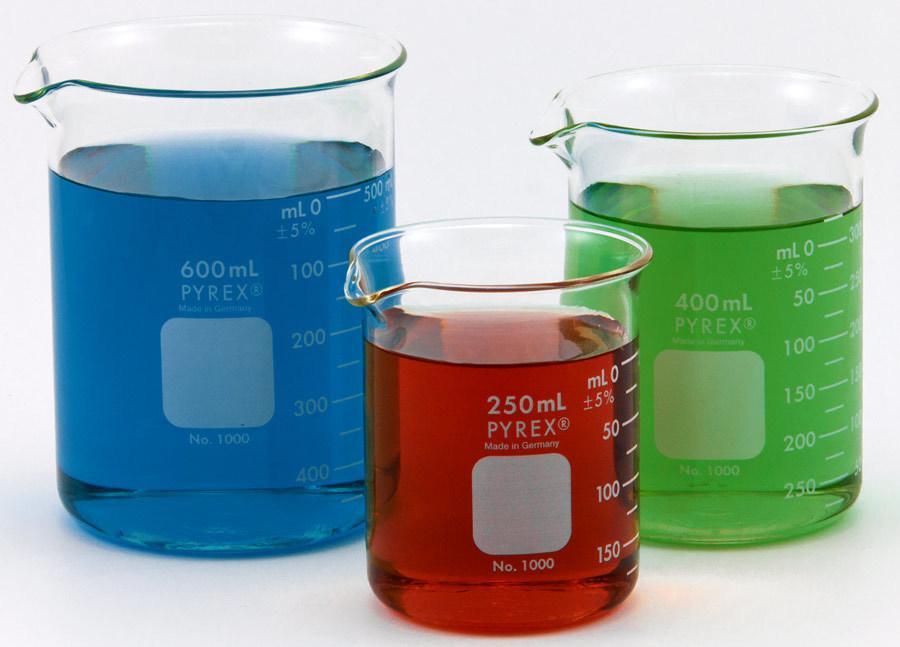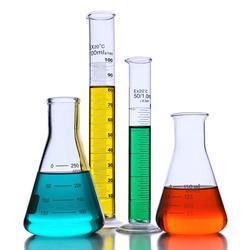The first image is the image on the left, the second image is the image on the right. Assess this claim about the two images: "In at least one image there are three cylinders filled with different colors of water.". Correct or not? Answer yes or no. Yes. The first image is the image on the left, the second image is the image on the right. Examine the images to the left and right. Is the description "Three containers with brightly colored liquid sit together in the image on the left." accurate? Answer yes or no. Yes. 